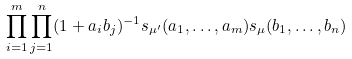Convert formula to latex. <formula><loc_0><loc_0><loc_500><loc_500>\prod _ { i = 1 } ^ { m } \prod _ { j = 1 } ^ { n } ( 1 + a _ { i } b _ { j } ) ^ { - 1 } s _ { \mu ^ { \prime } } ( a _ { 1 } , \dots , a _ { m } ) s _ { \mu } ( b _ { 1 } , \dots , b _ { n } )</formula> 